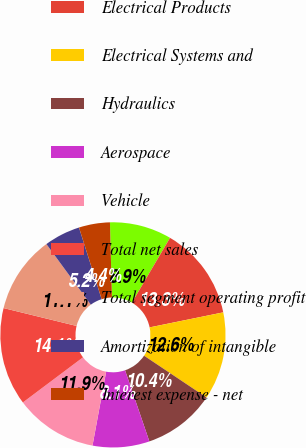Convert chart to OTSL. <chart><loc_0><loc_0><loc_500><loc_500><pie_chart><fcel>Business Segment Information<fcel>Electrical Products<fcel>Electrical Systems and<fcel>Hydraulics<fcel>Aerospace<fcel>Vehicle<fcel>Total net sales<fcel>Total segment operating profit<fcel>Amortization of intangible<fcel>Interest expense - net<nl><fcel>8.89%<fcel>13.33%<fcel>12.59%<fcel>10.37%<fcel>8.15%<fcel>11.85%<fcel>14.07%<fcel>11.11%<fcel>5.19%<fcel>4.45%<nl></chart> 